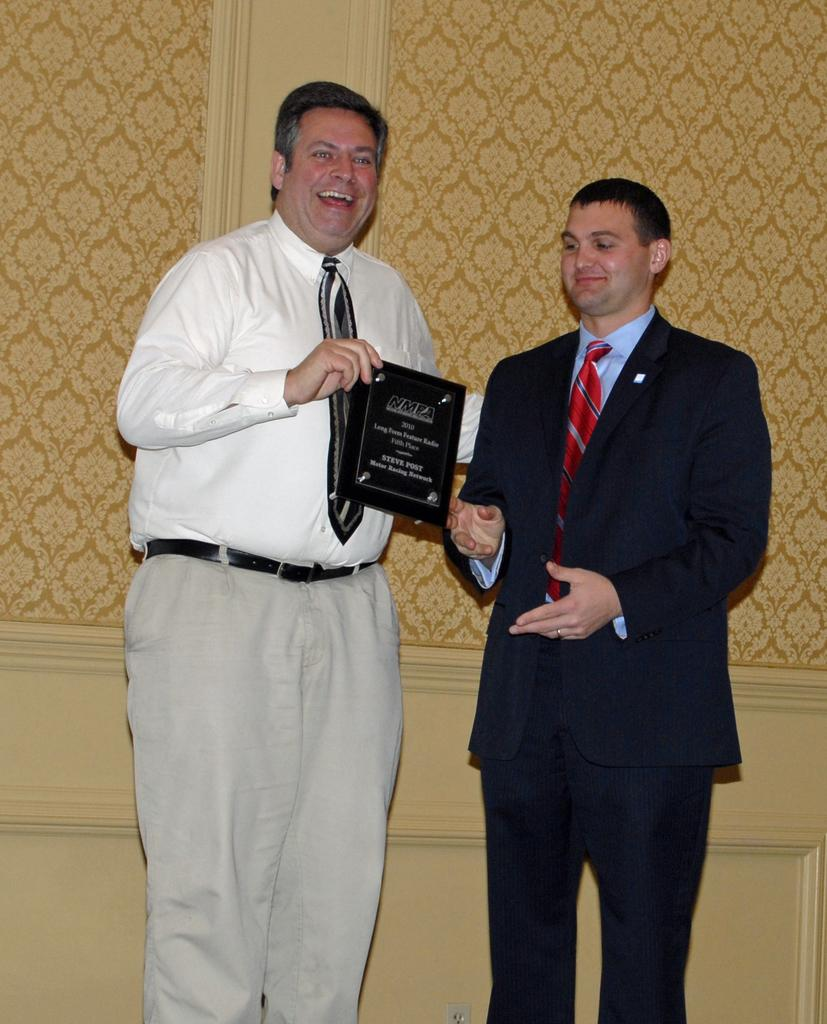How many people are in the image? There are two men in the image. What is one of the men holding? One of the men is holding a shield. What can be seen in the background of the image? There is a wall in the background of the image. How many friends are visible in the image? There is no information about friends in the image; it only shows two men. What type of light bulb is being used in the image? There is no light bulb present in the image. 